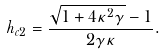<formula> <loc_0><loc_0><loc_500><loc_500>h _ { c 2 } = \frac { \sqrt { 1 + 4 \kappa ^ { 2 } \gamma } - 1 } { 2 \gamma \kappa } .</formula> 